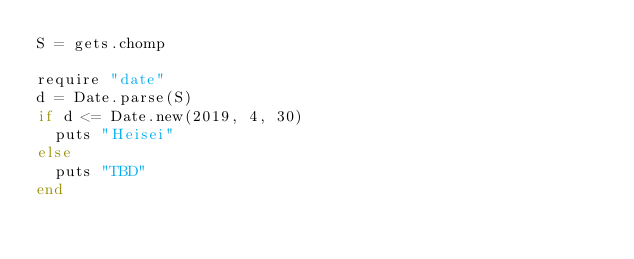<code> <loc_0><loc_0><loc_500><loc_500><_Ruby_>S = gets.chomp

require "date"
d = Date.parse(S)
if d <= Date.new(2019, 4, 30)
  puts "Heisei"
else
  puts "TBD"
end
</code> 